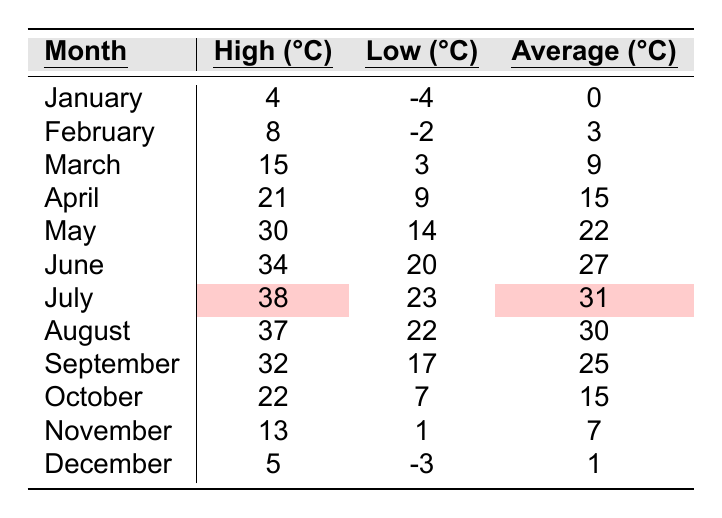What is the highest average temperature recorded in Tashkent? Looking at the "Average (°C)" column, the highest average temperature is found in July, which is 31°C.
Answer: 31°C Which month has the lowest minimum temperature? The "Low (°C)" column shows that January has the lowest temperature of -4°C.
Answer: January What is the average temperature for the month of April? From the "Average (°C)" column, April's average temperature is 15°C.
Answer: 15°C In which month does Tashkent experience the highest temperature? Reviewing the "High (°C)" column, July has the highest temperature at 38°C.
Answer: July What is the difference between the highest and lowest average temperatures? The highest average temperature is 31°C in July, and the lowest is 0°C in January. The difference is 31 - 0 = 31°C.
Answer: 31°C Is the average temperature in December greater than in November? December has an average of 1°C, and November has an average of 7°C. Since 1°C is less than 7°C, the statement is false.
Answer: No Which month has an average temperature greater than 20°C? From the table, May (22°C), June (27°C), and July (31°C) have average temperatures greater than 20°C.
Answer: May, June, July What is the average temperature for the first half of the year (January to June)? The average temperatures for the first half of the year are: 0 (Jan), 3 (Feb), 9 (Mar), 15 (Apr), 22 (May), and 27 (Jun). The total is 0 + 3 + 9 + 15 + 22 + 27 = 76°C, and there are 6 months, so the average is 76/6 ≈ 12.67°C.
Answer: Approximately 12.67°C Which month has the highest low temperature? The "Low (°C)" column indicates that July has the highest low temperature at 23°C.
Answer: July How many months have an average temperature below 10°C? The months with averages below 10°C are January (0°C), February (3°C), March (9°C), and November (7°C), totaling 4 months.
Answer: 4 months 